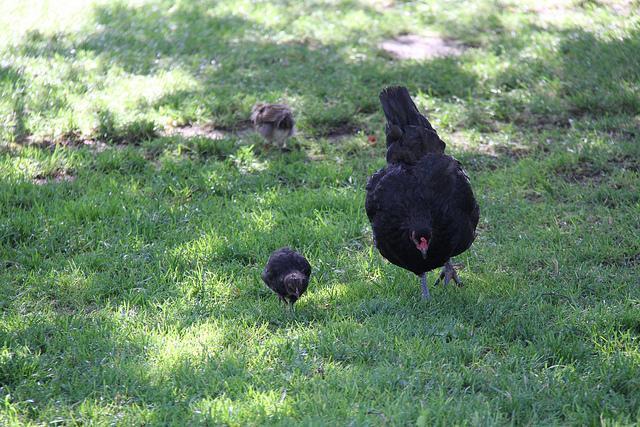How many feathered animals can you see?
Give a very brief answer. 2. How many birds are there?
Give a very brief answer. 2. 